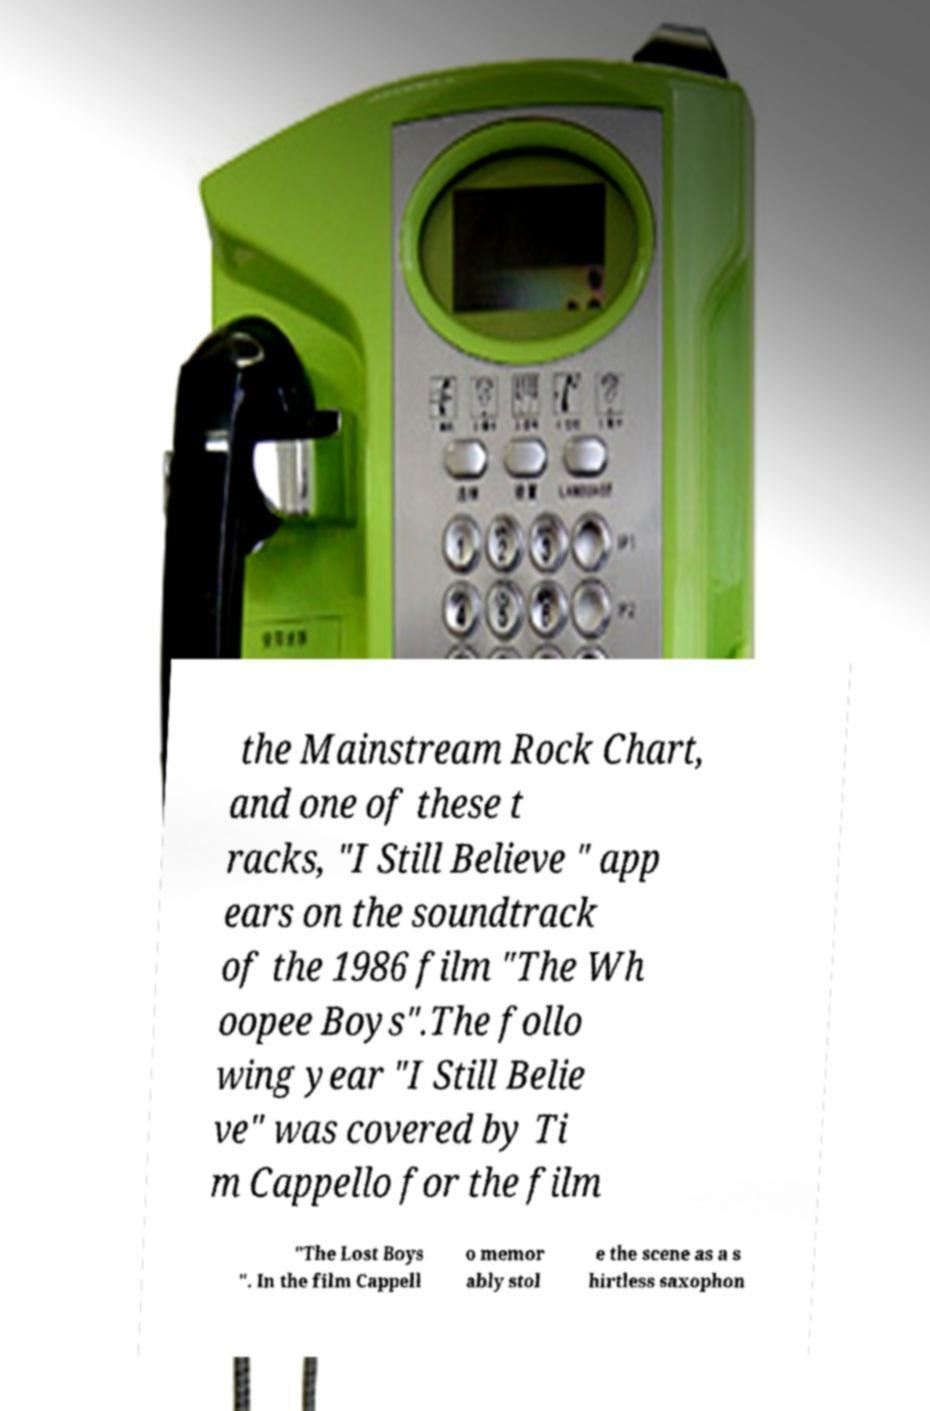For documentation purposes, I need the text within this image transcribed. Could you provide that? the Mainstream Rock Chart, and one of these t racks, "I Still Believe " app ears on the soundtrack of the 1986 film "The Wh oopee Boys".The follo wing year "I Still Belie ve" was covered by Ti m Cappello for the film "The Lost Boys ". In the film Cappell o memor ably stol e the scene as a s hirtless saxophon 